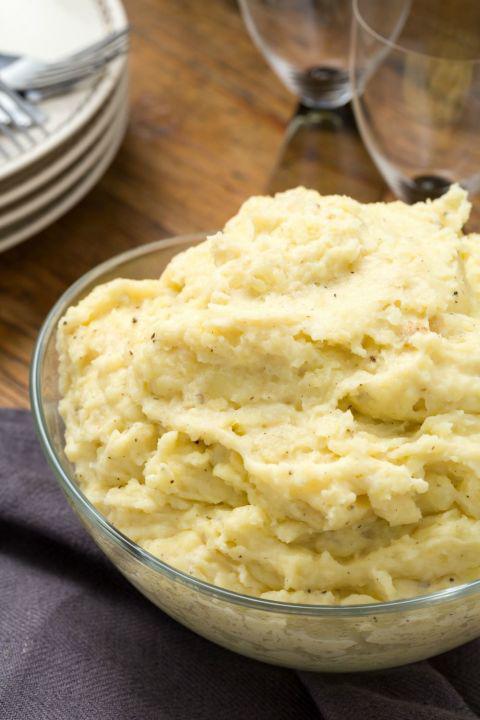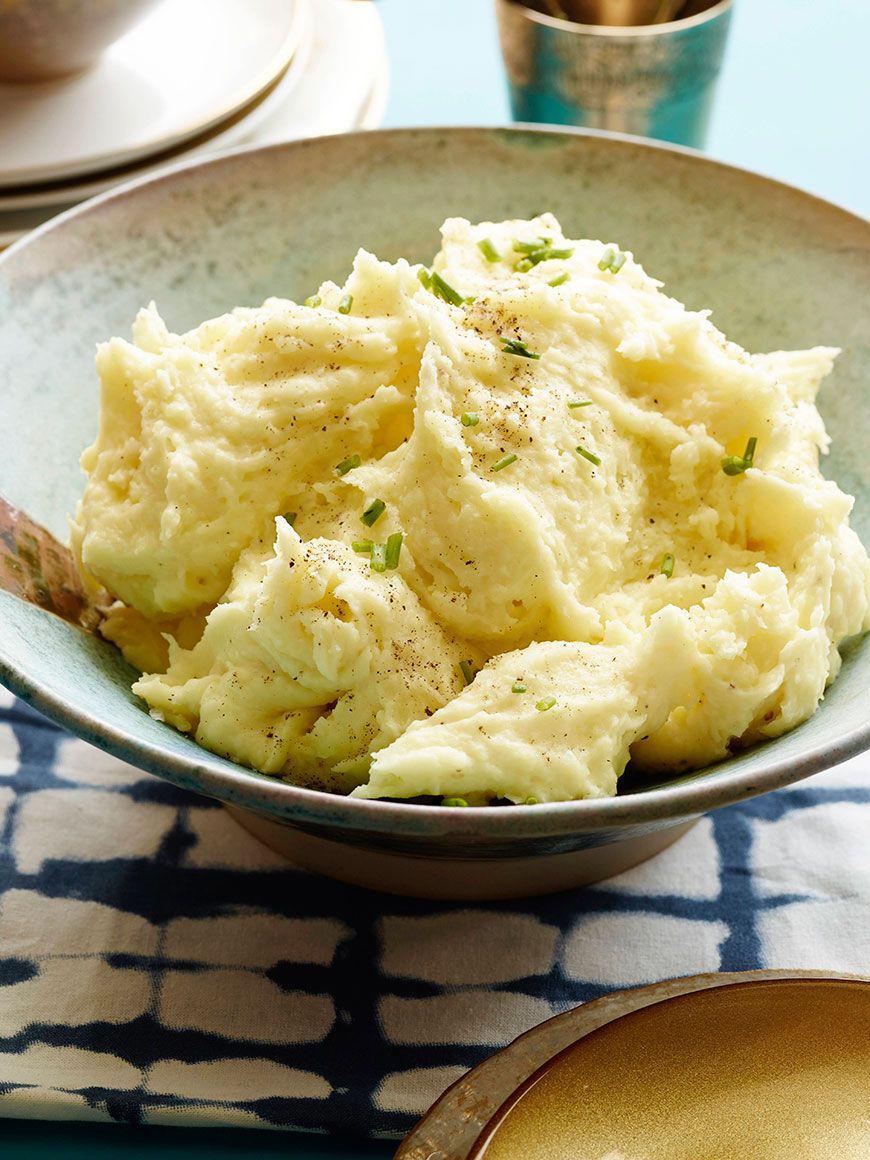The first image is the image on the left, the second image is the image on the right. Considering the images on both sides, is "Left image shows a silver spoon next to a bowl of mashed potatoes." valid? Answer yes or no. No. The first image is the image on the left, the second image is the image on the right. Evaluate the accuracy of this statement regarding the images: "There is a silver spoon near the bowl of food in the image on the left.". Is it true? Answer yes or no. No. 